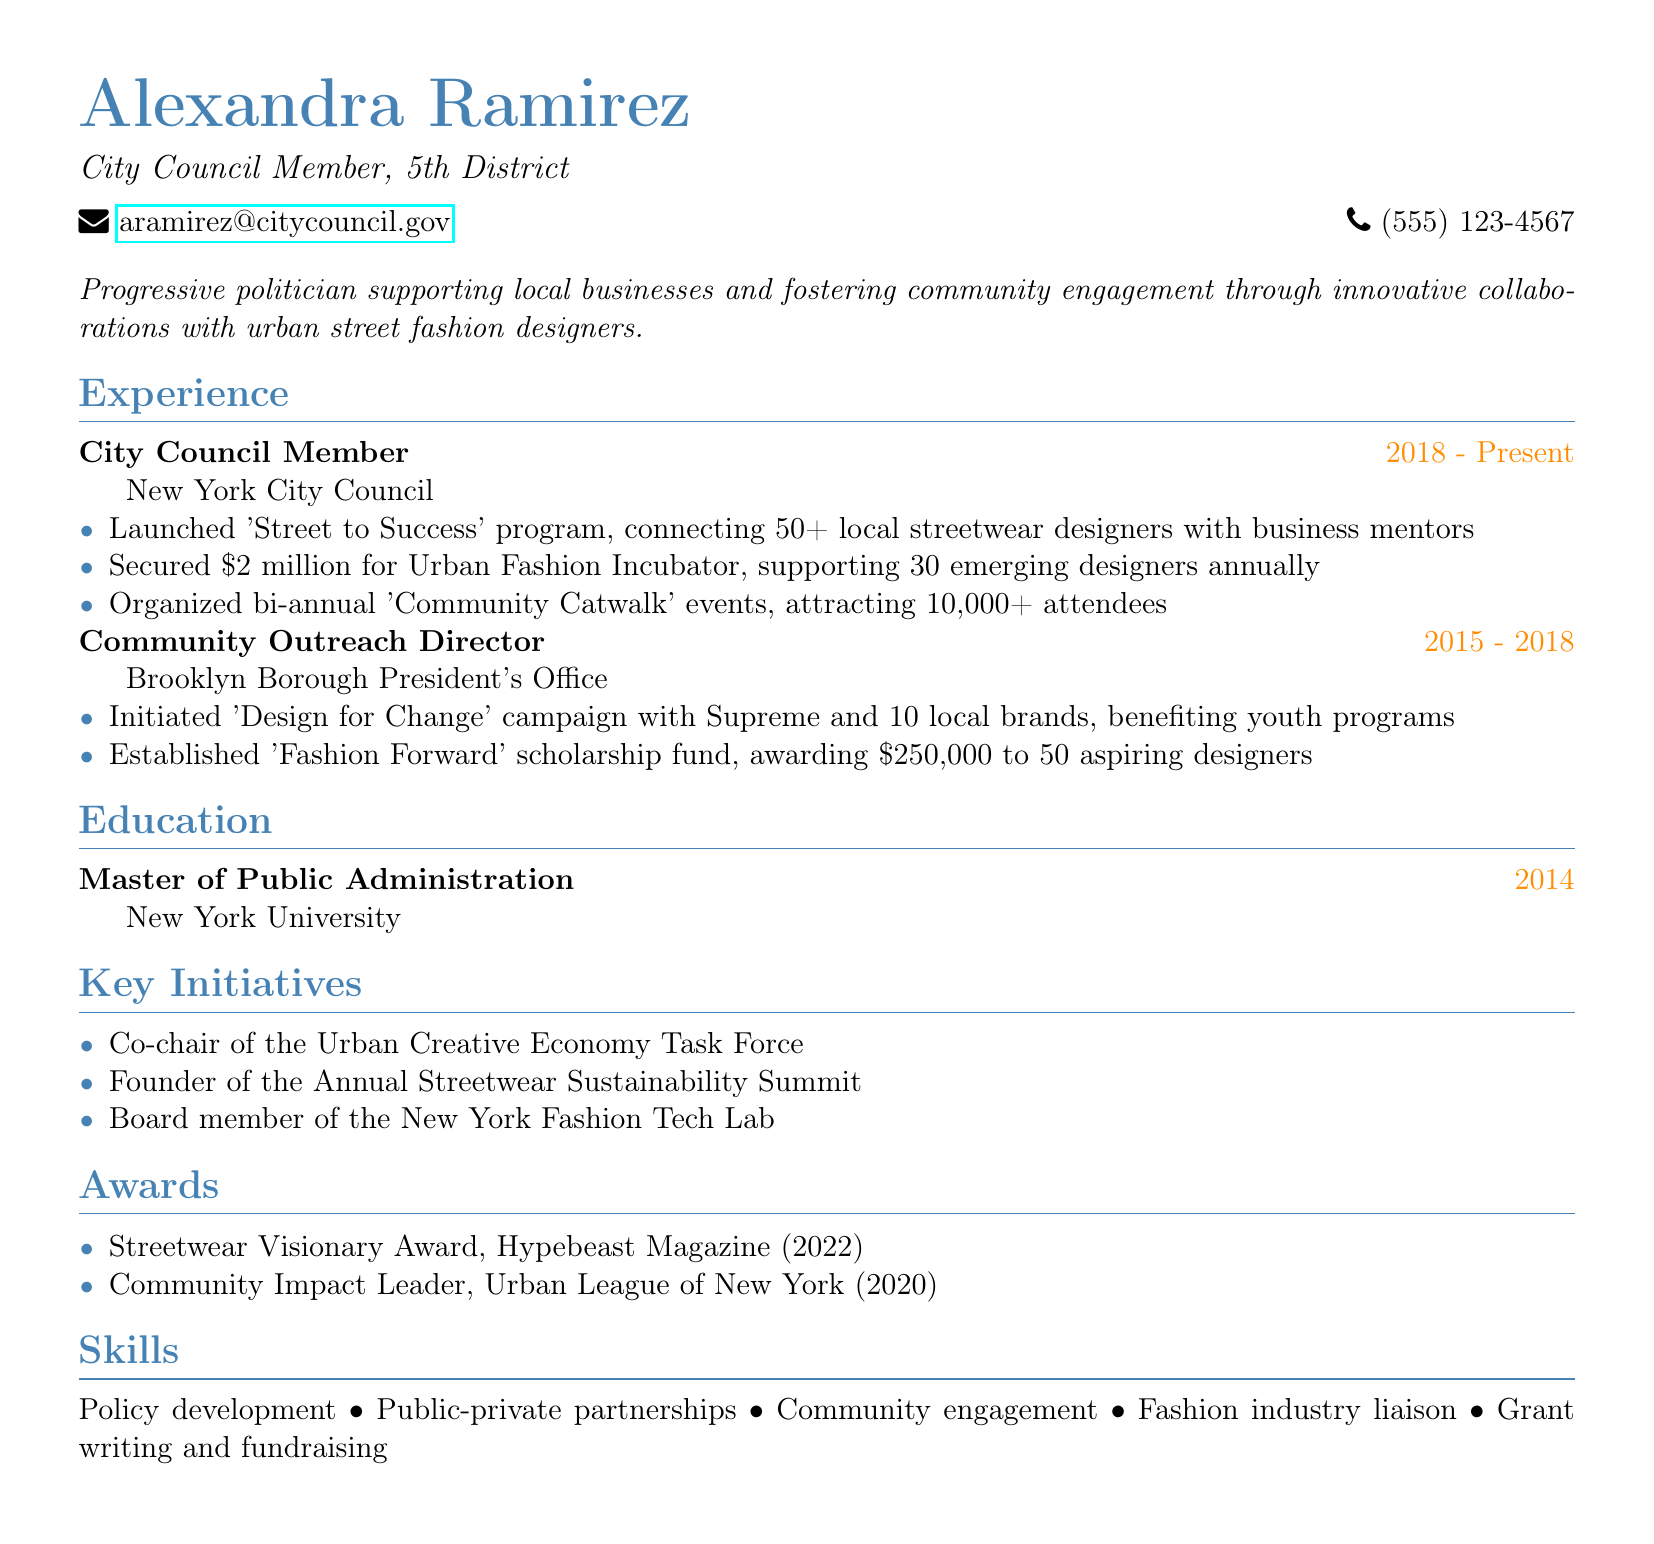what is the name of the politician? The name of the politician is presented at the top of the document.
Answer: Alexandra Ramirez what is the role of Alexandra Ramirez? The document states her title clearly under her name.
Answer: City Council Member, 5th District how many local streetwear designers were connected through the 'Street to Success' program? The document specifies the number of designers involved in the program.
Answer: 50+ what was the funding amount secured for the Urban Fashion Incubator? The CV lists the exact funding amount allocated for the incubator initiative.
Answer: $2 million what scholarship fund was established for aspiring designers? The document mentions a specific scholarship fund aimed at supporting designers.
Answer: Fashion Forward what is the duration of Alexandra Ramirez's experience as a City Council Member? The document provides the start and end years of her role on the council.
Answer: 2018 - Present which magazine awarded the Streetwear Visionary Award? The document indicates which publication recognized her contributions.
Answer: Hypebeast Magazine what initiative did Alexandra Ramirez co-chair? The CV lists one of her key initiatives related to the urban creative economy.
Answer: Urban Creative Economy Task Force how much funding was awarded to aspiring designers through the scholarship? The document states the total amount of the scholarship fund.
Answer: $250,000 